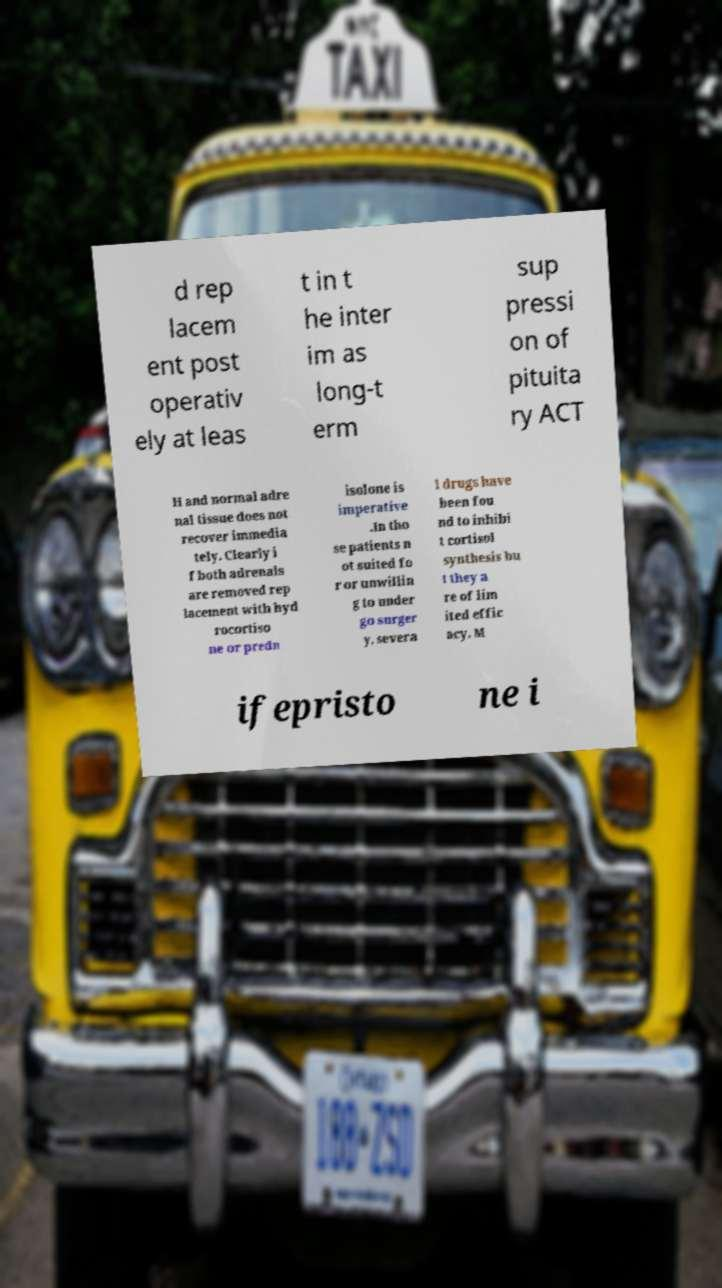Could you extract and type out the text from this image? d rep lacem ent post operativ ely at leas t in t he inter im as long-t erm sup pressi on of pituita ry ACT H and normal adre nal tissue does not recover immedia tely. Clearly i f both adrenals are removed rep lacement with hyd rocortiso ne or predn isolone is imperative .In tho se patients n ot suited fo r or unwillin g to under go surger y, severa l drugs have been fou nd to inhibi t cortisol synthesis bu t they a re of lim ited effic acy. M ifepristo ne i 